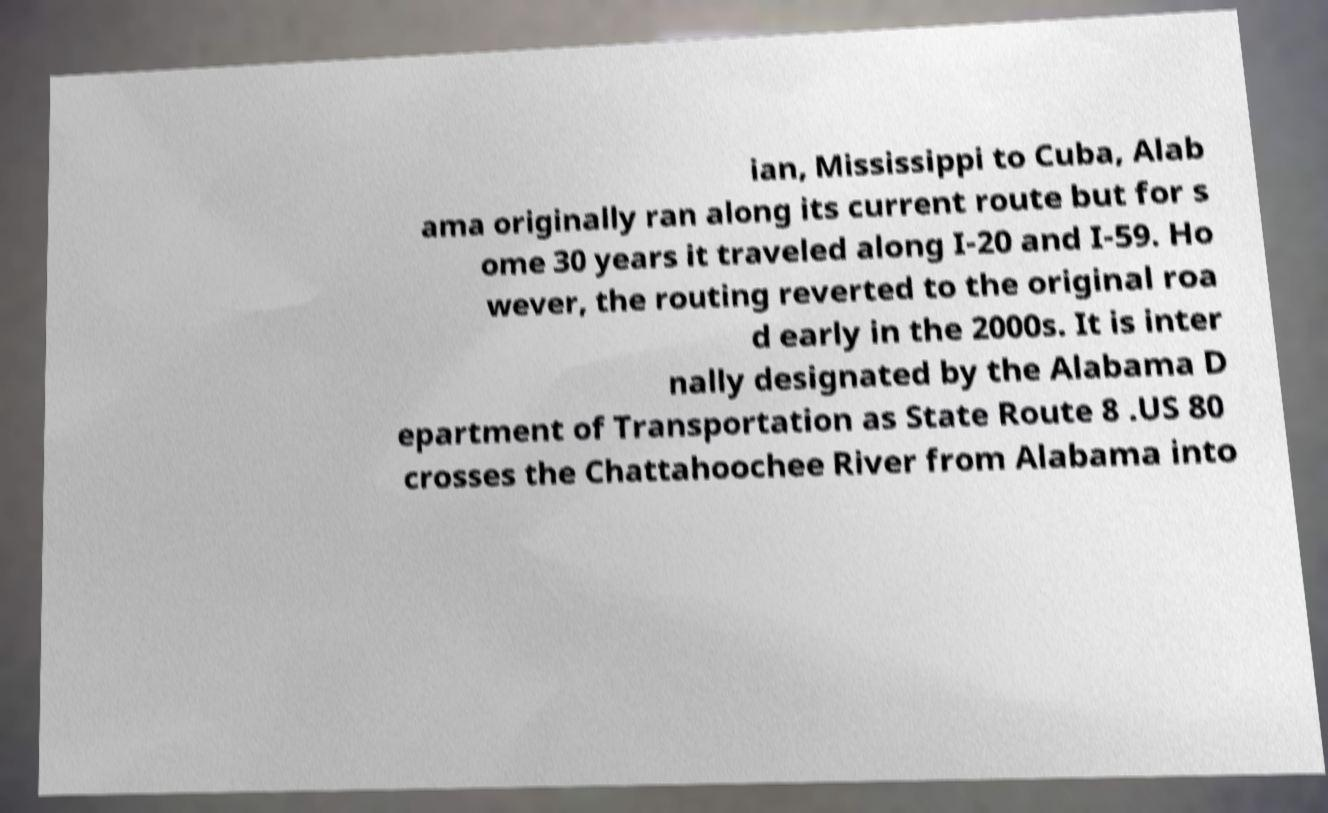What messages or text are displayed in this image? I need them in a readable, typed format. ian, Mississippi to Cuba, Alab ama originally ran along its current route but for s ome 30 years it traveled along I-20 and I-59. Ho wever, the routing reverted to the original roa d early in the 2000s. It is inter nally designated by the Alabama D epartment of Transportation as State Route 8 .US 80 crosses the Chattahoochee River from Alabama into 